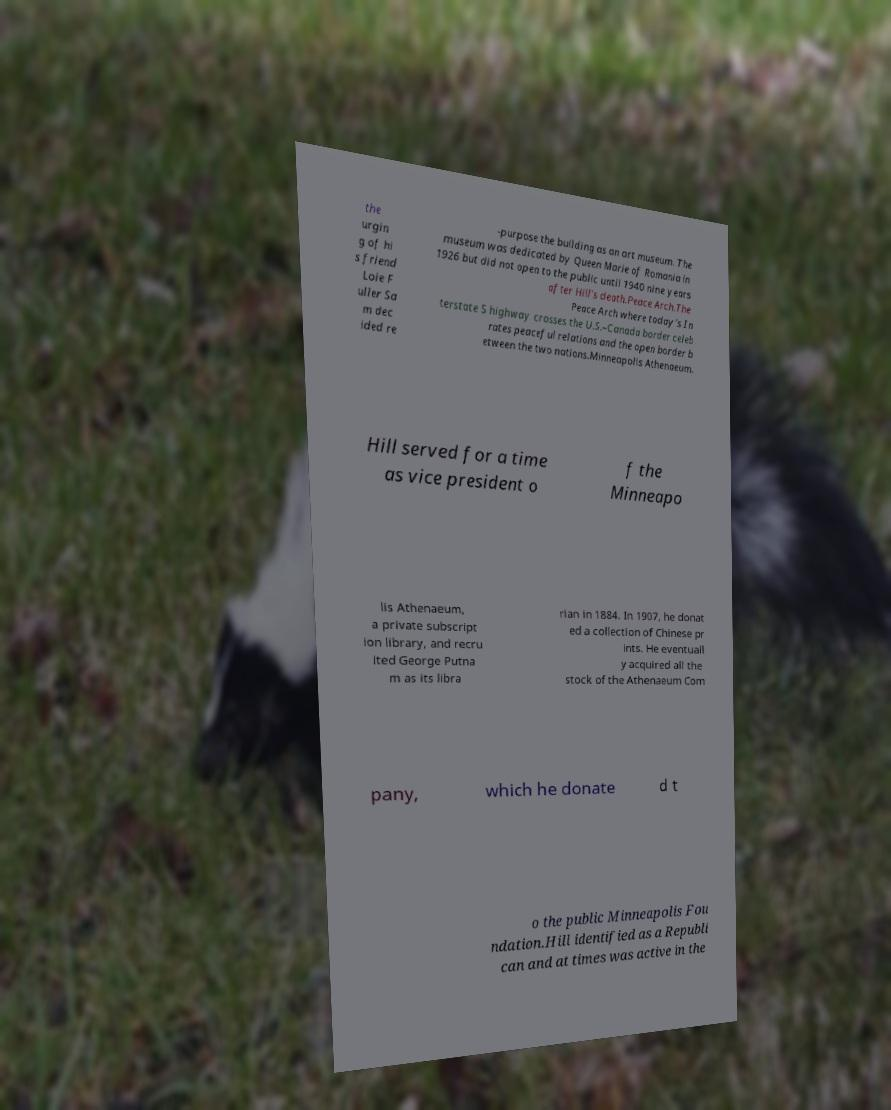Can you read and provide the text displayed in the image?This photo seems to have some interesting text. Can you extract and type it out for me? the urgin g of hi s friend Loie F uller Sa m dec ided re -purpose the building as an art museum. The museum was dedicated by Queen Marie of Romania in 1926 but did not open to the public until 1940 nine years after Hill's death.Peace Arch.The Peace Arch where today's In terstate 5 highway crosses the U.S.–Canada border celeb rates peaceful relations and the open border b etween the two nations.Minneapolis Athenaeum. Hill served for a time as vice president o f the Minneapo lis Athenaeum, a private subscript ion library, and recru ited George Putna m as its libra rian in 1884. In 1907, he donat ed a collection of Chinese pr ints. He eventuall y acquired all the stock of the Athenaeum Com pany, which he donate d t o the public Minneapolis Fou ndation.Hill identified as a Republi can and at times was active in the 